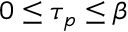<formula> <loc_0><loc_0><loc_500><loc_500>0 \leq \tau _ { p } \leq \beta</formula> 